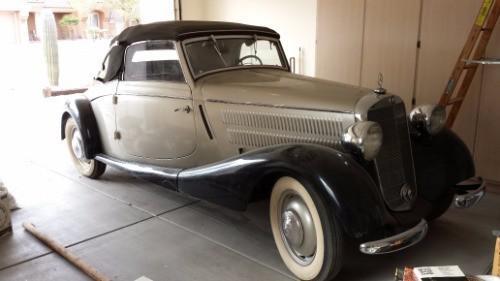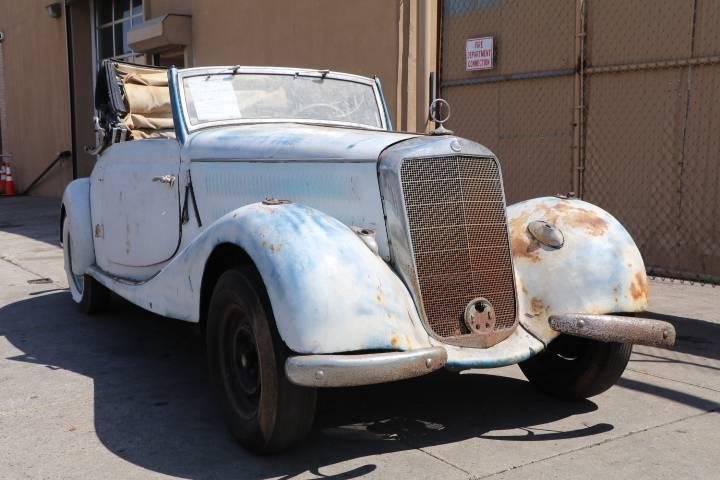The first image is the image on the left, the second image is the image on the right. Given the left and right images, does the statement "There are multiple cars behind a parked classic car in one of the images." hold true? Answer yes or no. No. The first image is the image on the left, the second image is the image on the right. Analyze the images presented: Is the assertion "Both images show shiny painted exteriors of antique convertibles in good condition." valid? Answer yes or no. No. 